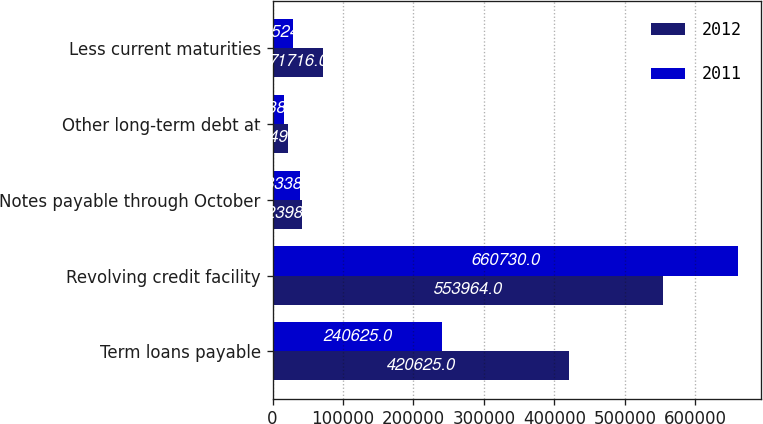Convert chart to OTSL. <chart><loc_0><loc_0><loc_500><loc_500><stacked_bar_chart><ecel><fcel>Term loans payable<fcel>Revolving credit facility<fcel>Notes payable through October<fcel>Other long-term debt at<fcel>Less current maturities<nl><fcel>2012<fcel>420625<fcel>553964<fcel>42398<fcel>21491<fcel>71716<nl><fcel>2011<fcel>240625<fcel>660730<fcel>38338<fcel>16383<fcel>29524<nl></chart> 